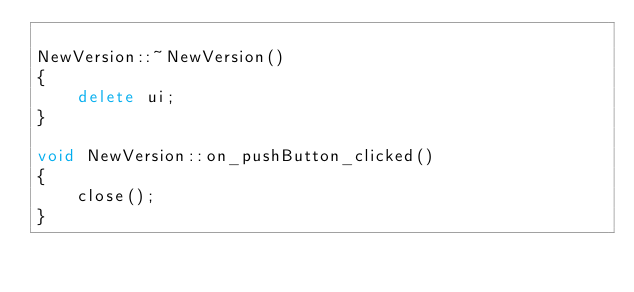Convert code to text. <code><loc_0><loc_0><loc_500><loc_500><_C++_>
NewVersion::~NewVersion()
{
    delete ui;
}

void NewVersion::on_pushButton_clicked()
{
    close();
}
</code> 